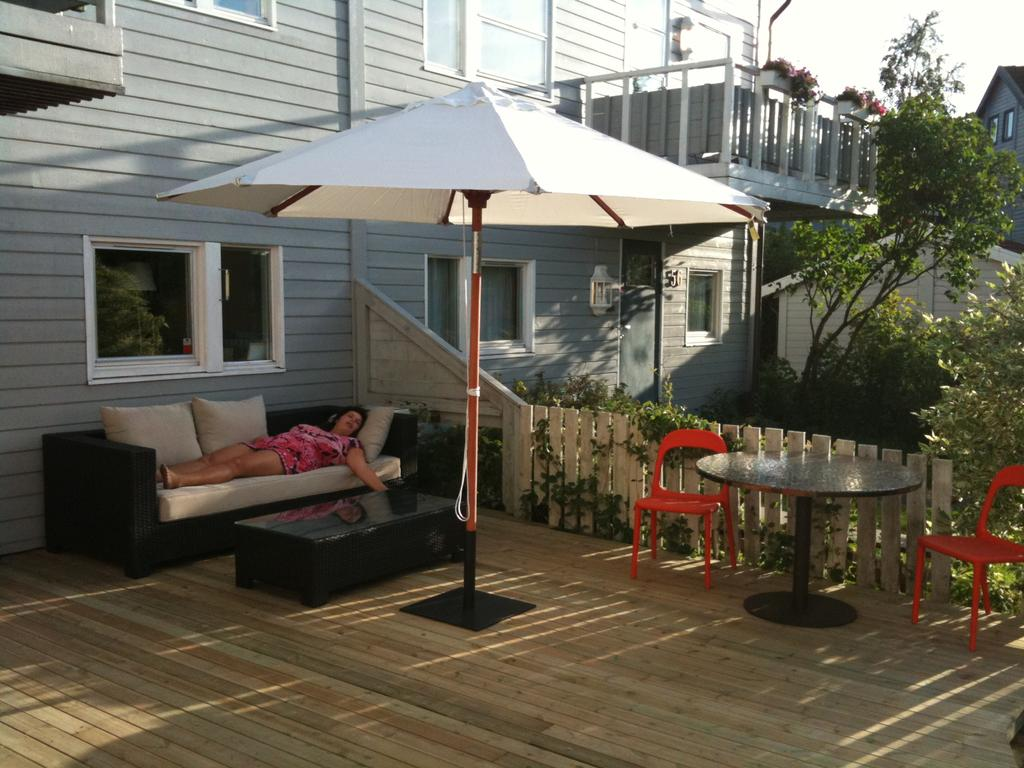Who is present in the image? There is a woman in the image. What is the woman doing in the image? The woman is lying on a couch. What can be seen in the background of the image? There is a building visible in the background of the image. How many oranges are being transported on the railway in the image? There are no oranges or railway present in the image. What is the value of the dime on the woman's forehead in the image? There is no dime or any other object on the woman's forehead in the image. 